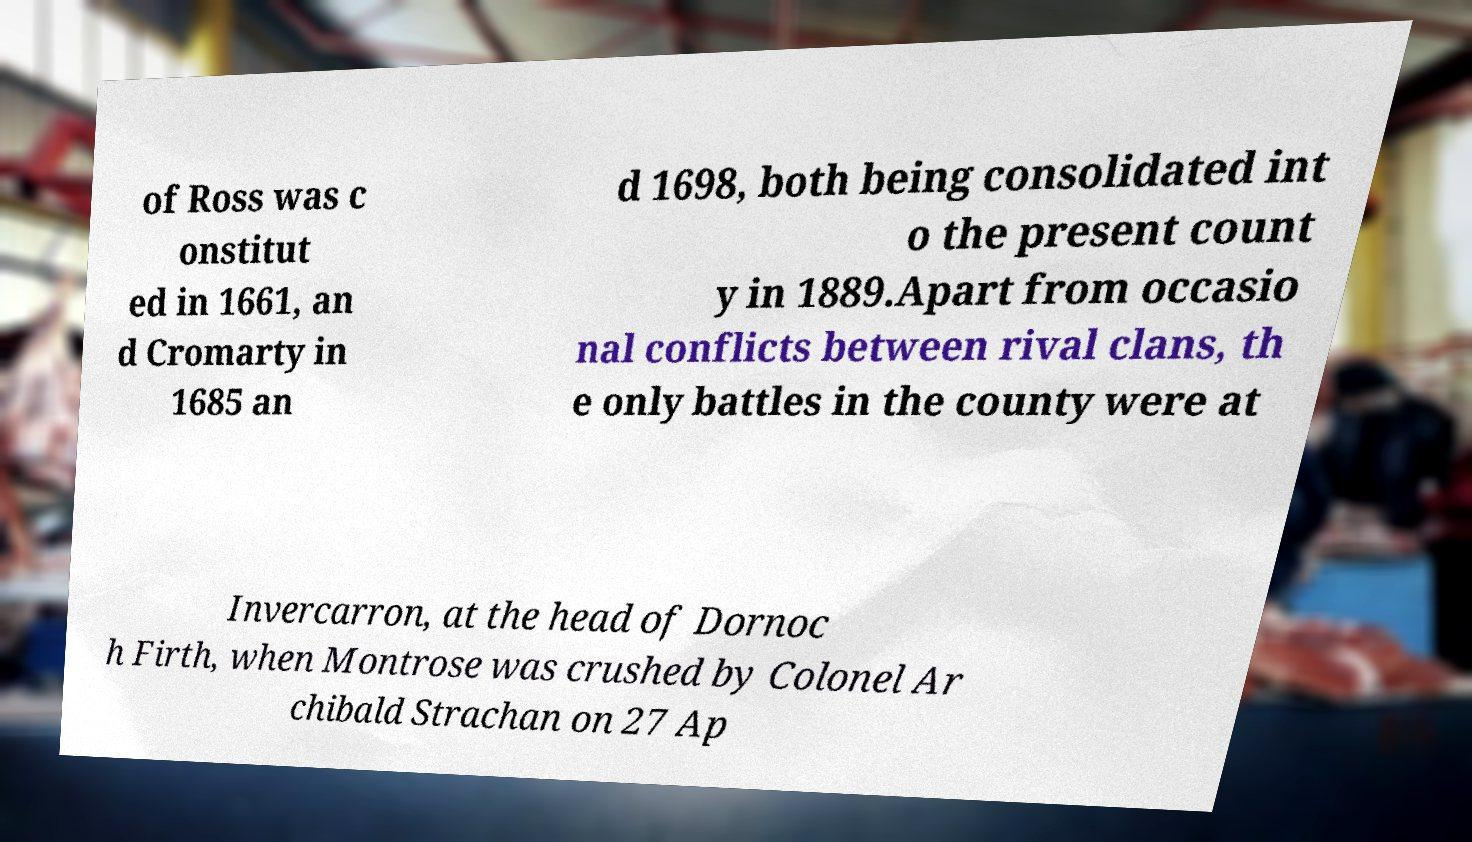Can you read and provide the text displayed in the image?This photo seems to have some interesting text. Can you extract and type it out for me? of Ross was c onstitut ed in 1661, an d Cromarty in 1685 an d 1698, both being consolidated int o the present count y in 1889.Apart from occasio nal conflicts between rival clans, th e only battles in the county were at Invercarron, at the head of Dornoc h Firth, when Montrose was crushed by Colonel Ar chibald Strachan on 27 Ap 